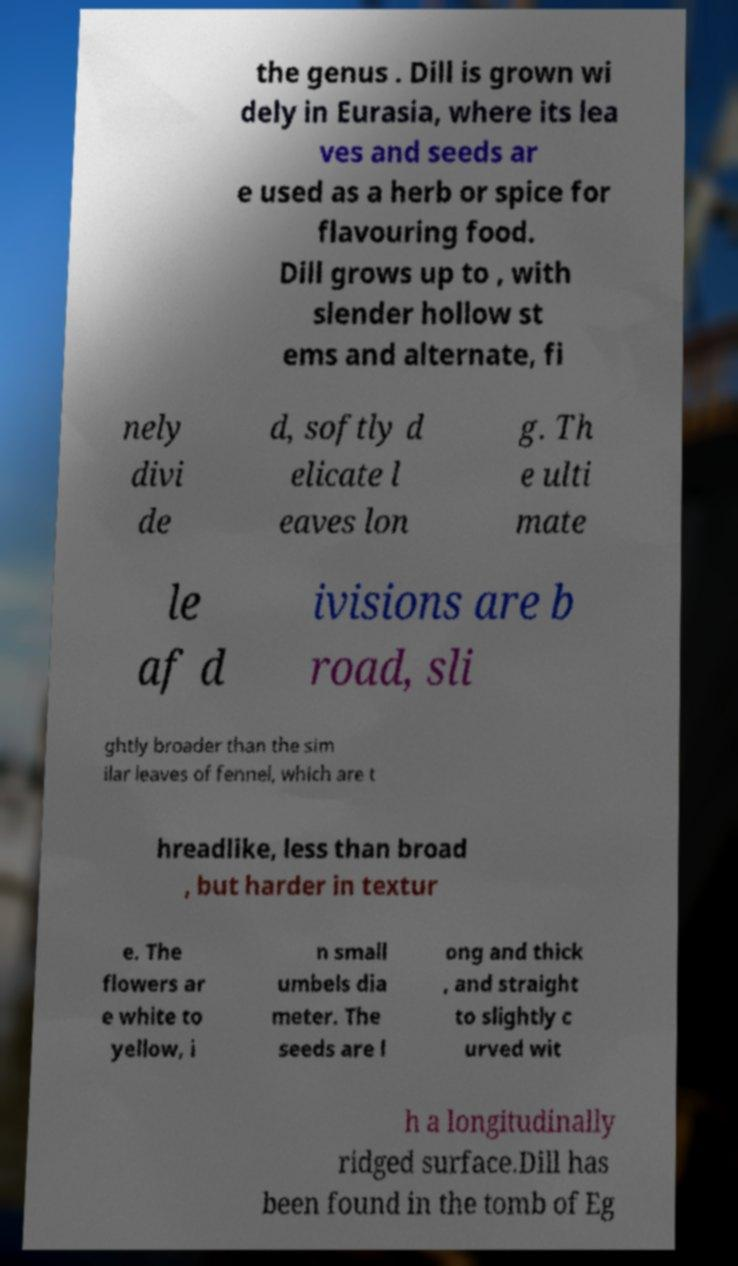Please identify and transcribe the text found in this image. the genus . Dill is grown wi dely in Eurasia, where its lea ves and seeds ar e used as a herb or spice for flavouring food. Dill grows up to , with slender hollow st ems and alternate, fi nely divi de d, softly d elicate l eaves lon g. Th e ulti mate le af d ivisions are b road, sli ghtly broader than the sim ilar leaves of fennel, which are t hreadlike, less than broad , but harder in textur e. The flowers ar e white to yellow, i n small umbels dia meter. The seeds are l ong and thick , and straight to slightly c urved wit h a longitudinally ridged surface.Dill has been found in the tomb of Eg 